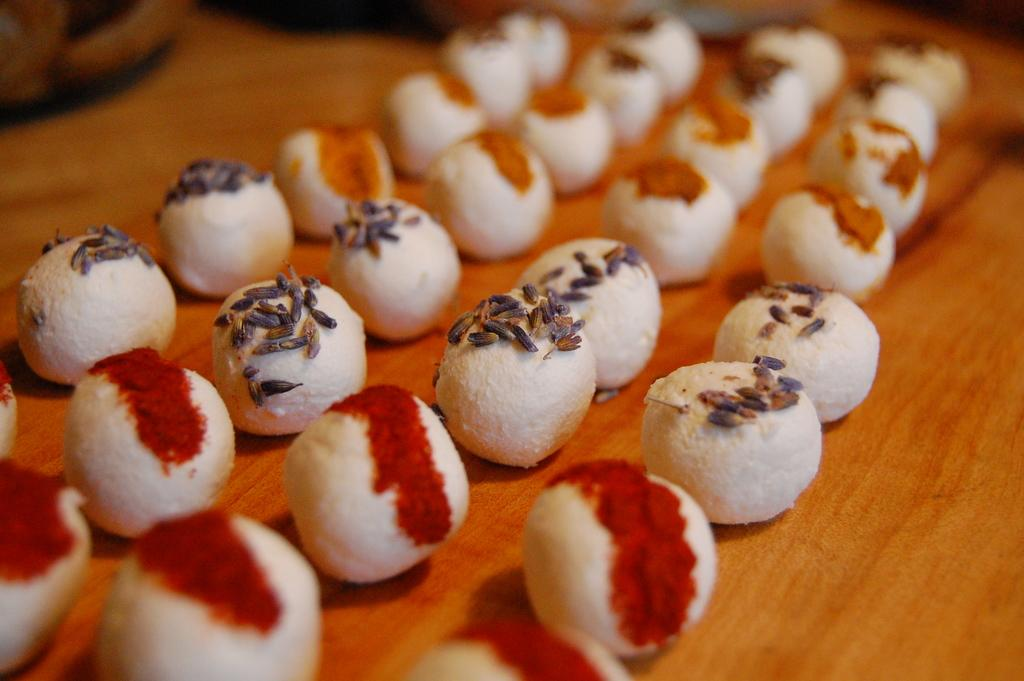What type of food contains cumin seeds in the image? The facts do not specify the type of food containing cumin seeds. Where is the food placed in the image? The food is placed on a table in the image. What type of argument is taking place between the parents in the image? There are no parents or argument present in the image; it only contains food with cumin seeds placed on a table. 